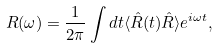Convert formula to latex. <formula><loc_0><loc_0><loc_500><loc_500>R ( \omega ) = \frac { 1 } { 2 \pi } \int d t \langle \hat { R } ( t ) \hat { R } \rangle e ^ { i \omega t } ,</formula> 